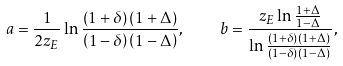<formula> <loc_0><loc_0><loc_500><loc_500>a = \frac { 1 } { 2 z _ { E } } \ln \frac { \left ( 1 + \delta \right ) \left ( 1 + \Delta \right ) } { \left ( 1 - \delta \right ) \left ( 1 - \Delta \right ) } , \quad b = \frac { z _ { E } \ln \frac { 1 + \Delta } { 1 - \Delta } } { \ln \frac { \left ( 1 + \delta \right ) \left ( 1 + \Delta \right ) } { \left ( 1 - \delta \right ) \left ( 1 - \Delta \right ) } } ,</formula> 